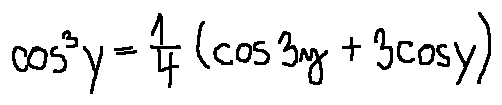<formula> <loc_0><loc_0><loc_500><loc_500>\cos ^ { 3 } y = \frac { 1 } { 4 } ( \cos 3 y + 3 \cos y )</formula> 